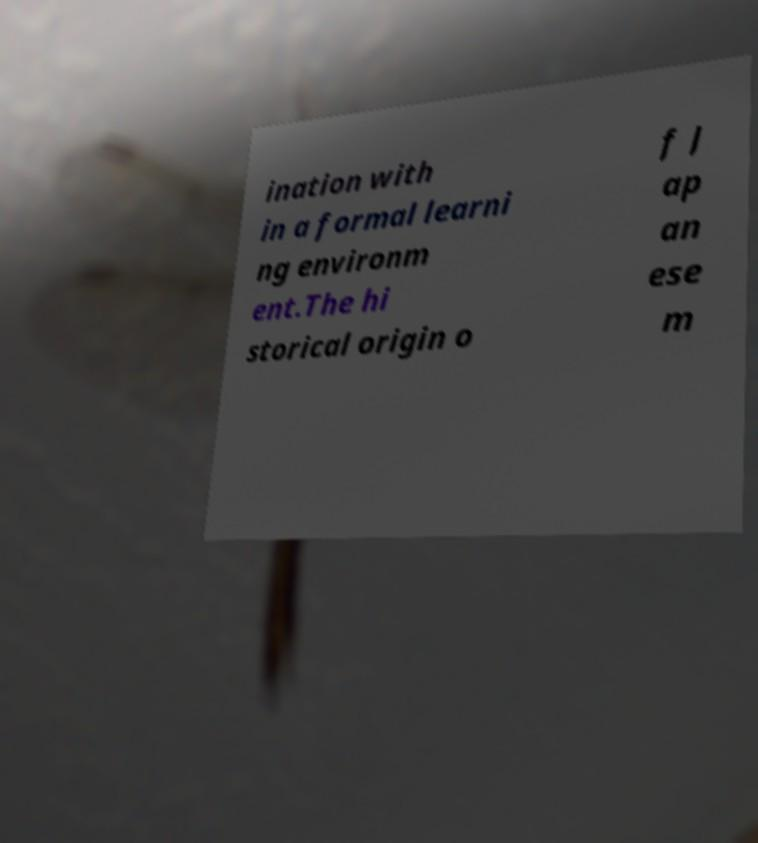There's text embedded in this image that I need extracted. Can you transcribe it verbatim? ination with in a formal learni ng environm ent.The hi storical origin o f J ap an ese m 